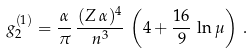Convert formula to latex. <formula><loc_0><loc_0><loc_500><loc_500>g _ { 2 } ^ { ( 1 ) } = \frac { \alpha } { \pi } \, \frac { ( Z \, \alpha ) ^ { 4 } } { n ^ { 3 } } \, \left ( 4 + \frac { 1 6 } { 9 } \, \ln \mu \right ) \, .</formula> 